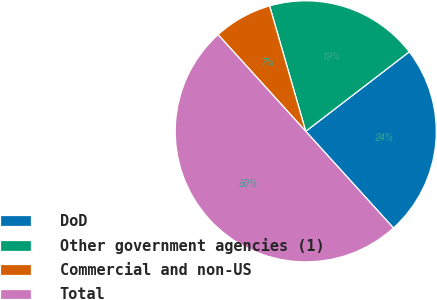Convert chart to OTSL. <chart><loc_0><loc_0><loc_500><loc_500><pie_chart><fcel>DoD<fcel>Other government agencies (1)<fcel>Commercial and non-US<fcel>Total<nl><fcel>23.7%<fcel>19.04%<fcel>7.26%<fcel>50.0%<nl></chart> 